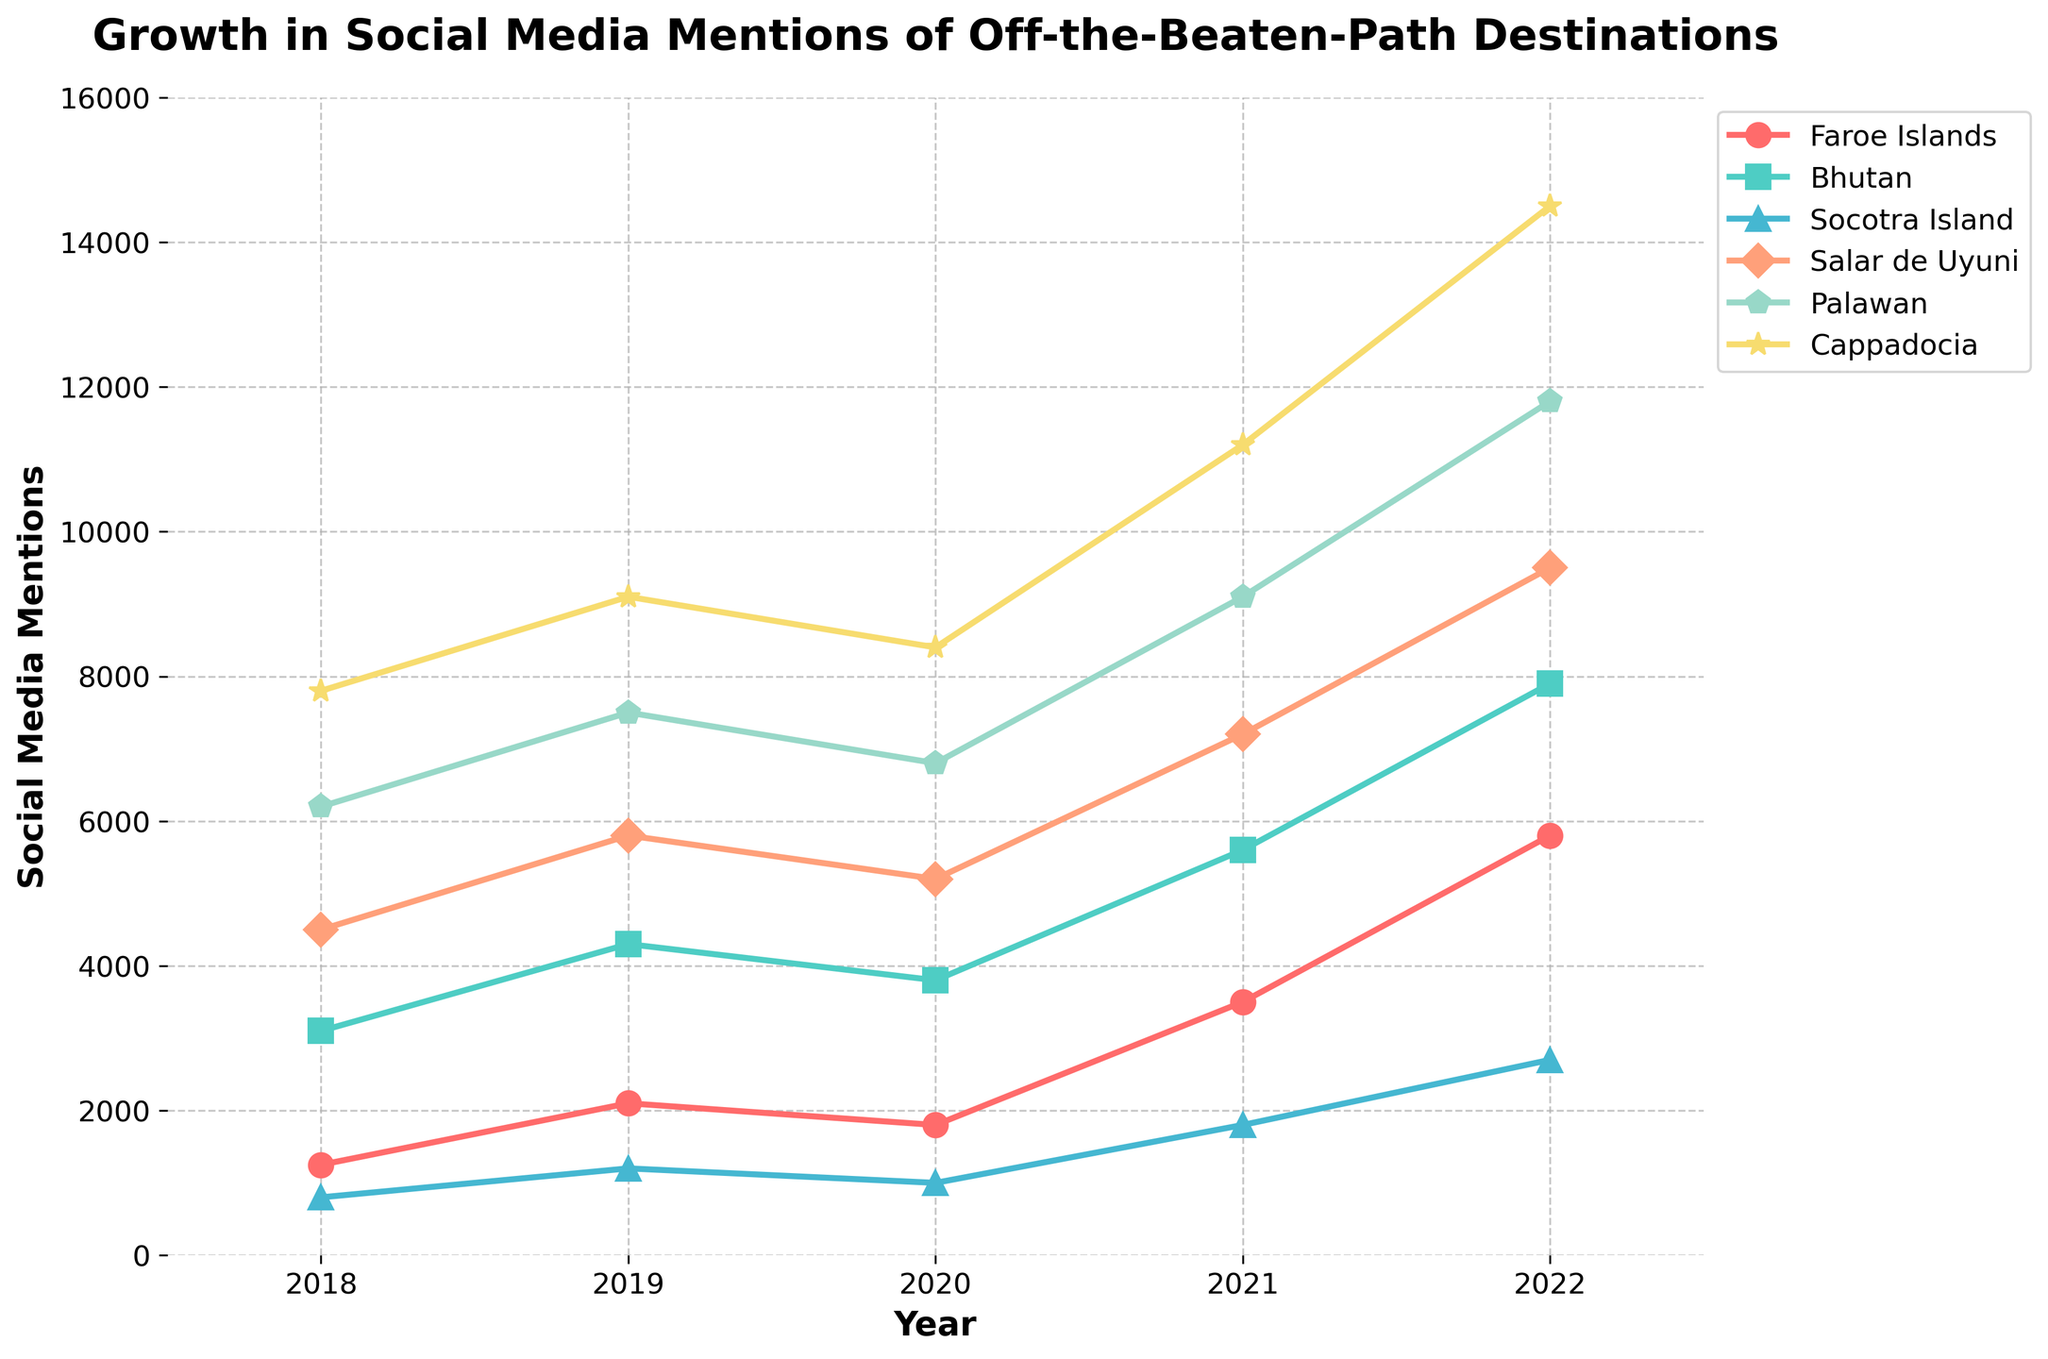Which destination had the highest social media mentions in 2022? By looking at the endpoint of the lines on the far right of the plot, the highest point is for "Palawan".
Answer: Palawan Which two destinations had the closest number of mentions in 2020? By comparing the points for each destination at the 2020 mark, "Salar de Uyuni" (5200) and "Palawan" (6800) are the closest in mentions.
Answer: Salar de Uyuni and Palawan Which destination saw the most significant increase in mentions from 2018 to 2022? The plot for "Faroe Islands" shows the steepest rise from 1250 mentions in 2018 to 5800 in 2022, totaling an increase of 4550.
Answer: Faroe Islands How did the social media mentions for Bhutan change from 2019 to 2020? The mentions for Bhutan decreased from 4300 in 2019 to 3800 in 2020. The difference is 4300 - 380 = 500.
Answer: Decreased by 500 What is the average social media mentions for Socotra Island across the years shown? Sum the mentions for Socotra Island across all years: 800 + 1200 + 1000 + 1800 + 2700 = 7500, and divide by 5: 7500 / 5 = 1500.
Answer: 1500 Which destination had consistently increasing mentions every year? Observing the plots, only "Cappadocia" had increasing mentions each consecutive year from 2018 to 2022.
Answer: Cappadocia Between which years did Palawan see the largest year-over-year increase in mentions? Between 2021 and 2022, Palawan went from 9100 to 11800. The increase is 11800 - 9100 = 2700, which is the largest year-over-year increase.
Answer: 2021 and 2022 If you combine the mentions for Faroe Islands and Bhutan in 2020, is it higher than the mentions of Cappadocia in the same year? Faroe Islands (1800) + Bhutan (3800) = 5600. Cappadocia had 8400 mentions in 2020. 5600 < 8400.
Answer: No Which destination had a fluctuation in social media mentions with at least one decrease over the years? "Socotra Island" showed a decrease in mentions from 2019 to 2020.
Answer: Socotra Island 